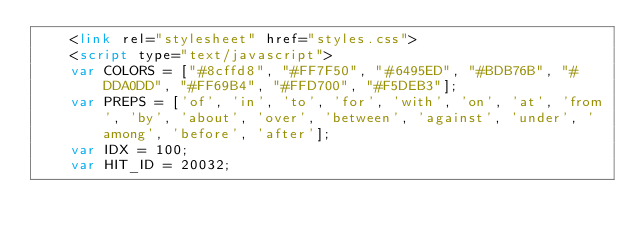Convert code to text. <code><loc_0><loc_0><loc_500><loc_500><_HTML_>	<link rel="stylesheet" href="styles.css">
	<script type="text/javascript">
	var COLORS = ["#8cffd8", "#FF7F50", "#6495ED", "#BDB76B", "#DDA0DD", "#FF69B4", "#FFD700", "#F5DEB3"];
	var PREPS = ['of', 'in', 'to', 'for', 'with', 'on', 'at', 'from', 'by', 'about', 'over', 'between', 'against', 'under', 'among', 'before', 'after'];
	var IDX = 100;
	var HIT_ID = 20032;</code> 